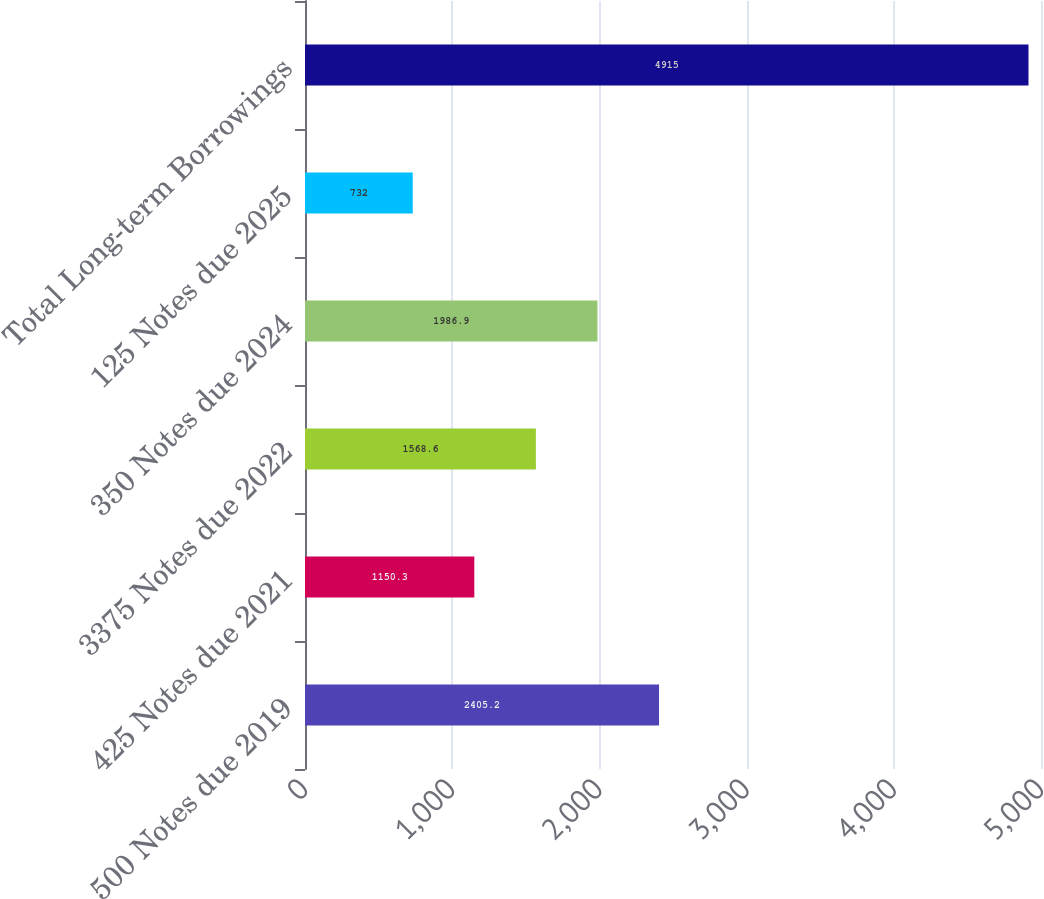Convert chart. <chart><loc_0><loc_0><loc_500><loc_500><bar_chart><fcel>500 Notes due 2019<fcel>425 Notes due 2021<fcel>3375 Notes due 2022<fcel>350 Notes due 2024<fcel>125 Notes due 2025<fcel>Total Long-term Borrowings<nl><fcel>2405.2<fcel>1150.3<fcel>1568.6<fcel>1986.9<fcel>732<fcel>4915<nl></chart> 